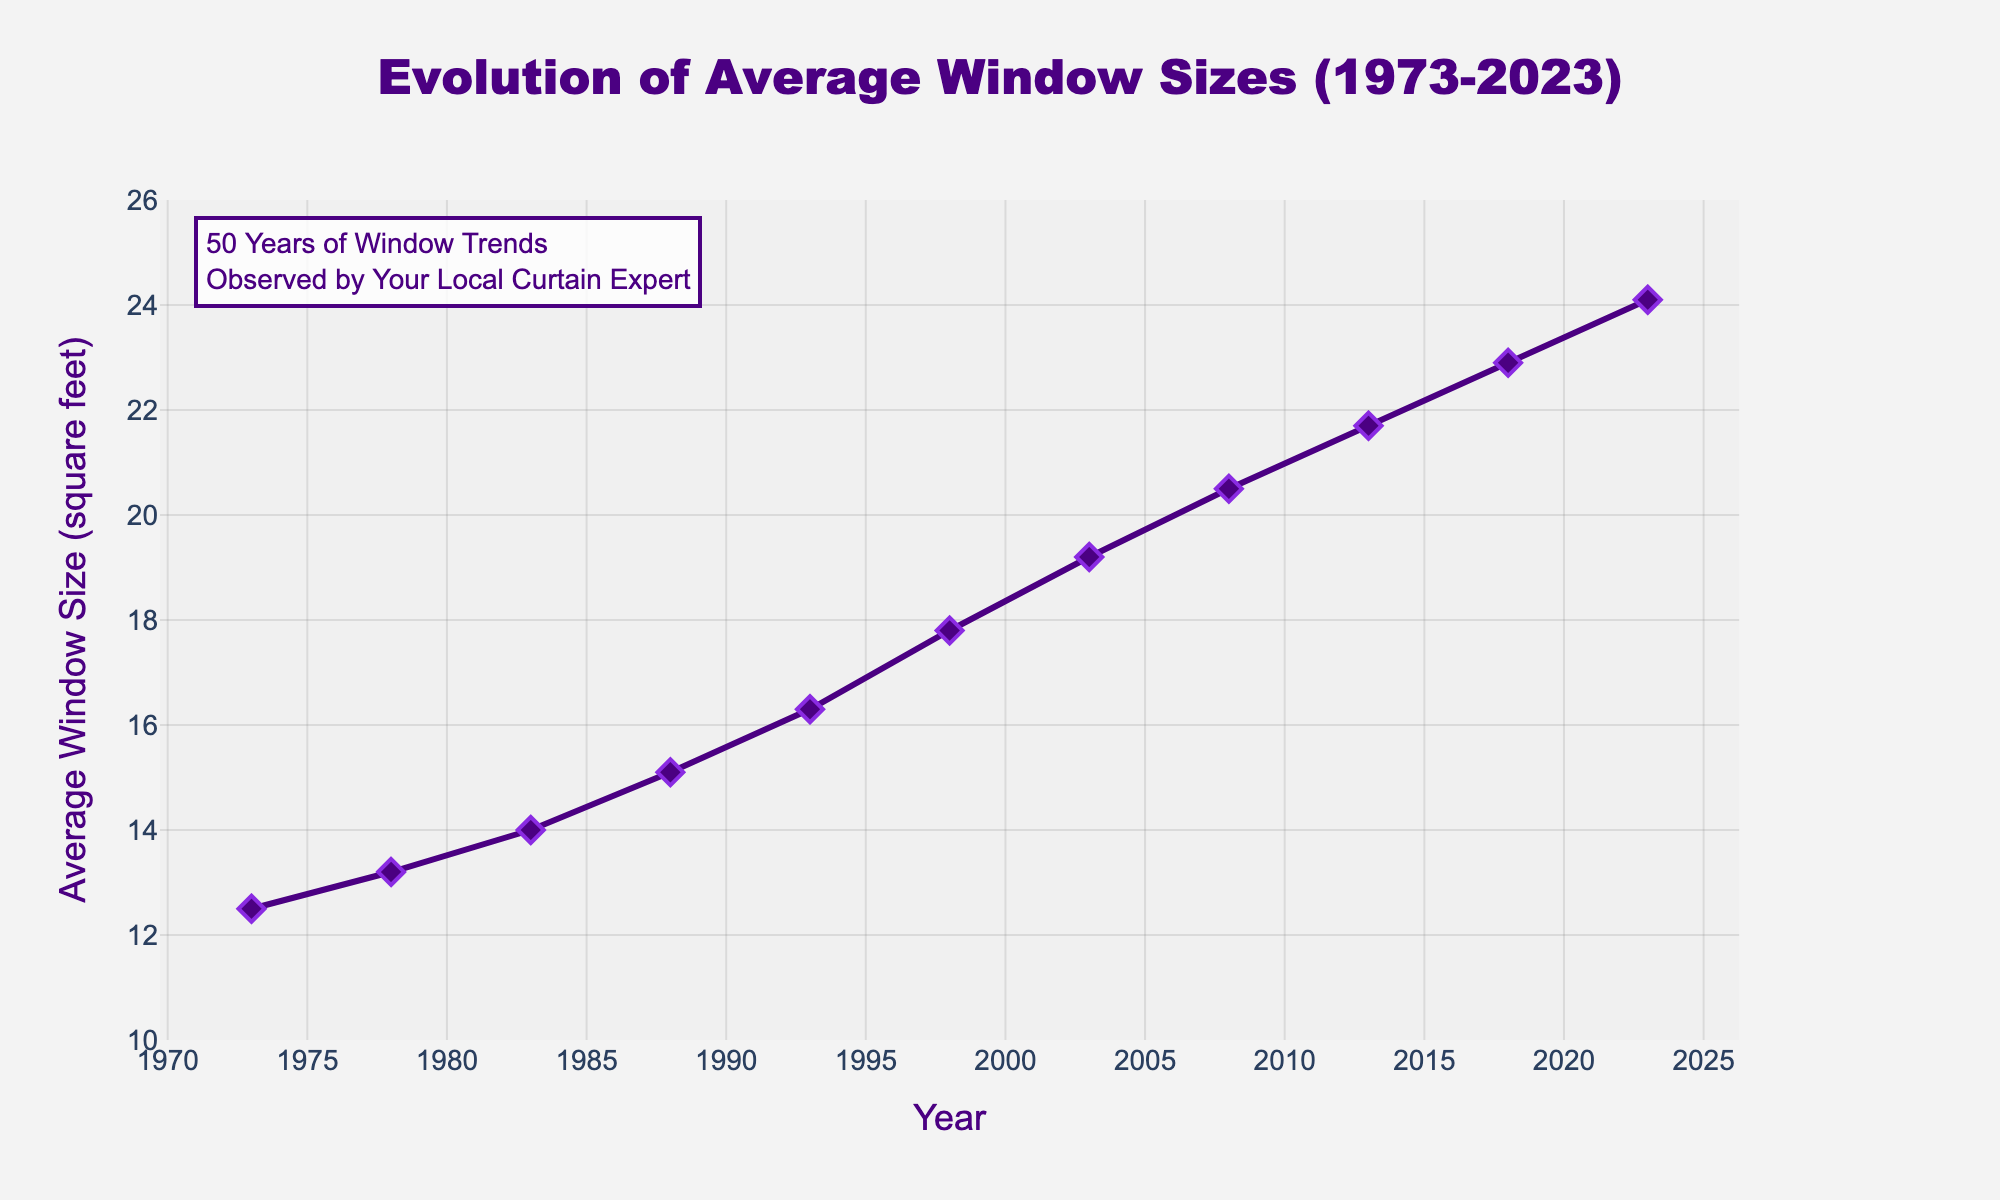What's the trend in average window sizes from 1973 to 2023? The average window size shows a consistent upward trend, increasing from 12.5 square feet in 1973 to 24.1 square feet in 2023. To observe this, one can look at the line connecting the data points and see the steady increase over time.
Answer: Increasing What's the difference in average window size between 1973 and 2023? To find the difference, subtract the average window size in 1973 (12.5 square feet) from the average window size in 2023 (24.1 square feet). This yields: 24.1 - 12.5 = 11.6 square feet.
Answer: 11.6 square feet Which decade saw the largest increase in average window size? To determine this, calculate the increase for each decade: 1973-1983 (14.0-12.5=1.5), 1983-1993 (16.3-14.0=2.3), 1993-2003 (19.2-16.3=2.9), 2003-2013 (21.7-19.2=2.5), and 2013-2023 (24.1-21.7=2.4). The decade 1993-2003 saw the largest increase, which is 2.9 square feet.
Answer: 1993-2003 By how much did the average window size increase from 1988 to 2008? First, find the average window sizes for 1988 (15.1 square feet) and 2008 (20.5 square feet), then subtract the former from the latter: 20.5 - 15.1 = 5.4 square feet.
Answer: 5.4 square feet How does the average window size in 2018 compare to 2003? The average window size in 2018 is 22.9 square feet, while it was 19.2 square feet in 2003. Therefore, the size in 2018 is larger.
Answer: Larger What is the average increase in window size per decade? Calculate the total increase in window size from 1973 to 2023, which is 24.1 - 12.5 = 11.6 square feet. Then, divide by the number of decades (5): 11.6 / 5 = 2.32 square feet per decade.
Answer: 2.32 square feet per decade What was the average window size in the year 1998? Observe the data point corresponding to 1998, which shows an average window size of 17.8 square feet.
Answer: 17.8 square feet Is there any year in the dataset where the average window size decreased compared to the previous year? Examine the trend line on the graph, which shows a consistent increase in average window size with no decreases between any consecutive years.
Answer: No, there is no decrease How much did the average window size grow from 1978 to 2013? Subtract the average window size in 1978 (13.2 square feet) from the average window size in 2013 (21.7 square feet): 21.7 - 13.2 = 8.5 square feet.
Answer: 8.5 square feet How does the trend observed in this chart impact curtain business over the past 50 years? As the average window size has been increasing over the past 50 years, there is likely a higher demand for larger curtains. Curtains need to cover larger windows, so the market for more expansive and possibly more expensive curtain options could have increased.
Answer: Increased demand for larger curtains 